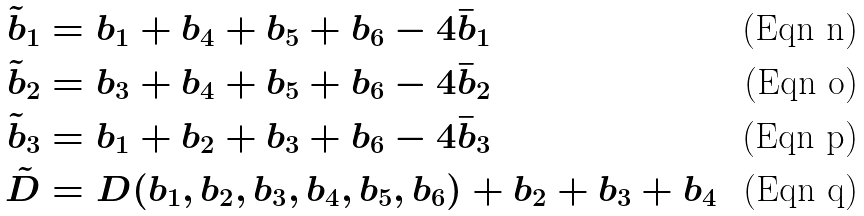<formula> <loc_0><loc_0><loc_500><loc_500>\tilde { b } _ { 1 } & = b _ { 1 } + b _ { 4 } + b _ { 5 } + b _ { 6 } - 4 \bar { b } _ { 1 } \\ \tilde { b } _ { 2 } & = b _ { 3 } + b _ { 4 } + b _ { 5 } + b _ { 6 } - 4 \bar { b } _ { 2 } \\ \tilde { b } _ { 3 } & = b _ { 1 } + b _ { 2 } + b _ { 3 } + b _ { 6 } - 4 \bar { b } _ { 3 } \\ \tilde { D } & = D ( b _ { 1 } , b _ { 2 } , b _ { 3 } , b _ { 4 } , b _ { 5 } , b _ { 6 } ) + b _ { 2 } + b _ { 3 } + b _ { 4 }</formula> 